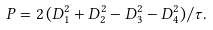<formula> <loc_0><loc_0><loc_500><loc_500>P = 2 \, ( D _ { 1 } ^ { 2 } + D _ { 2 } ^ { 2 } - D _ { 3 } ^ { 2 } - D _ { 4 } ^ { 2 } ) / \tau .</formula> 